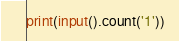Convert code to text. <code><loc_0><loc_0><loc_500><loc_500><_Python_>print(input().count('1'))</code> 